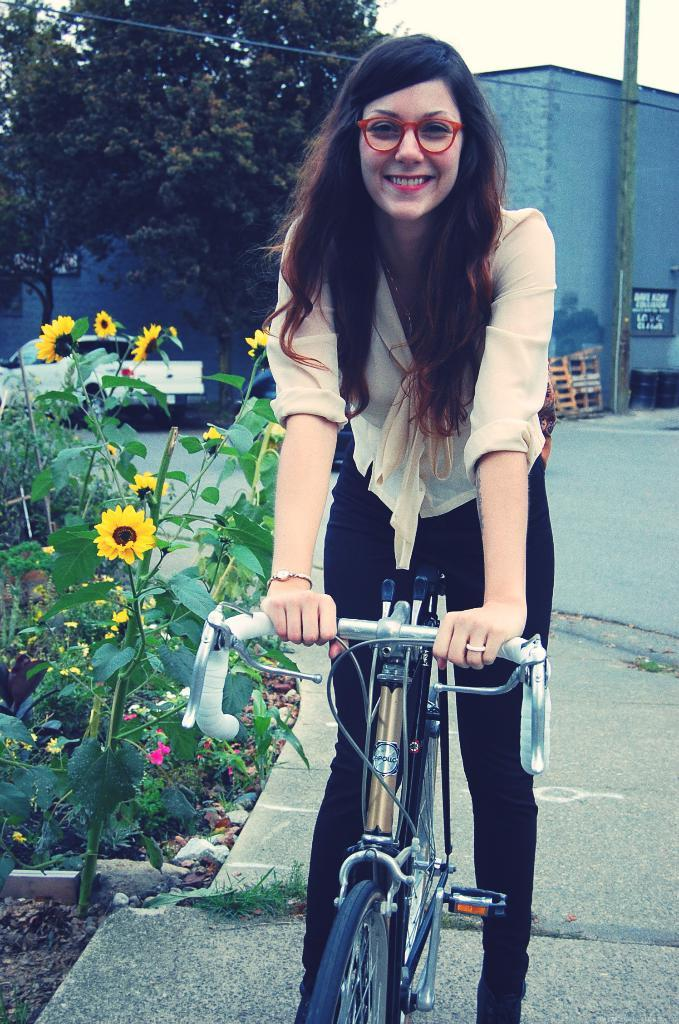Who is the main subject in the image? There is a woman in the image. What is the woman doing in the image? The woman is riding a bicycle. What is the woman's facial expression in the image? The woman is smiling. What type of natural scenery can be seen in the image? There are trees visible in the image. What else is present in the image besides the woman and trees? There is a vehicle in the image. What type of camp can be seen in the image? There is no camp present in the image. What kind of shock is the woman experiencing in the image? There is no indication of the woman experiencing any shock in the image. 